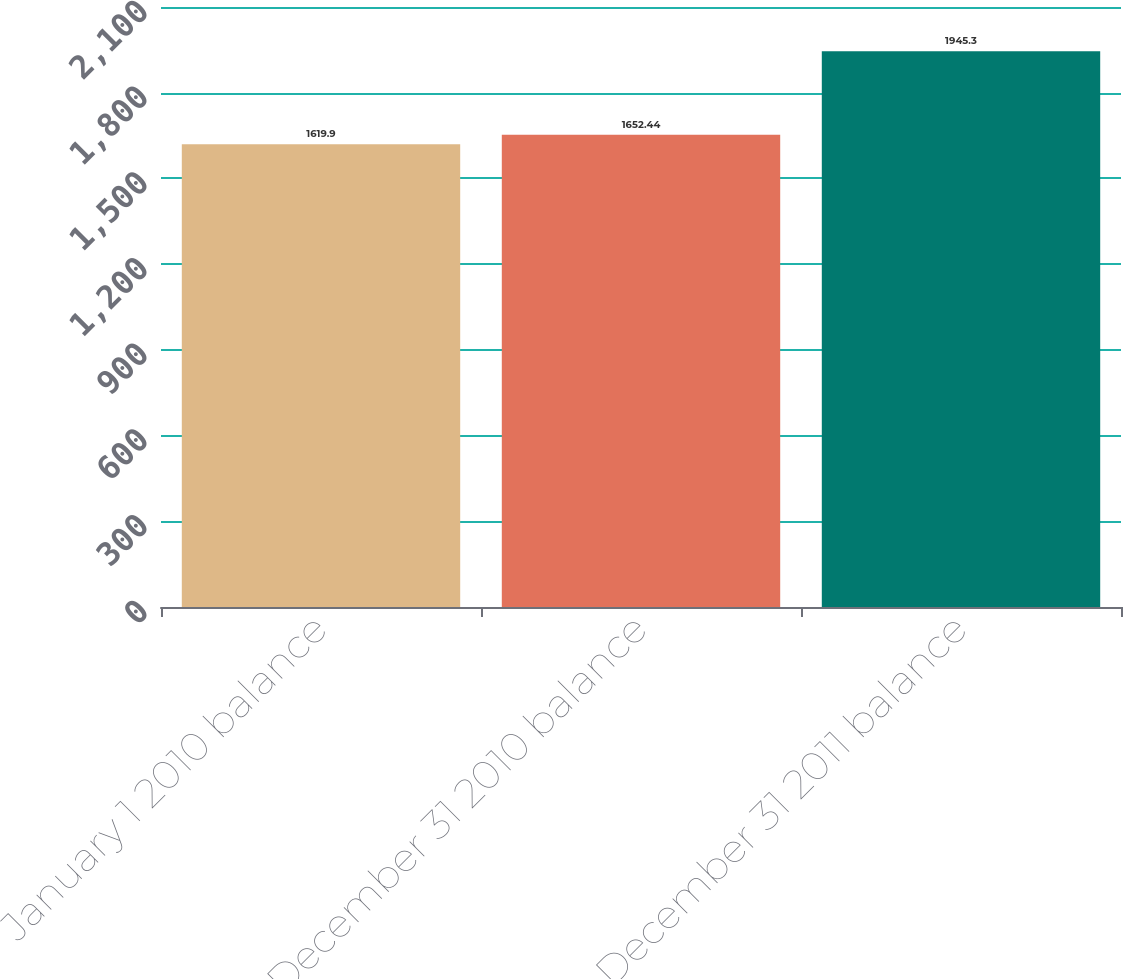<chart> <loc_0><loc_0><loc_500><loc_500><bar_chart><fcel>January 1 2010 balance<fcel>December 31 2010 balance<fcel>December 31 2011 balance<nl><fcel>1619.9<fcel>1652.44<fcel>1945.3<nl></chart> 